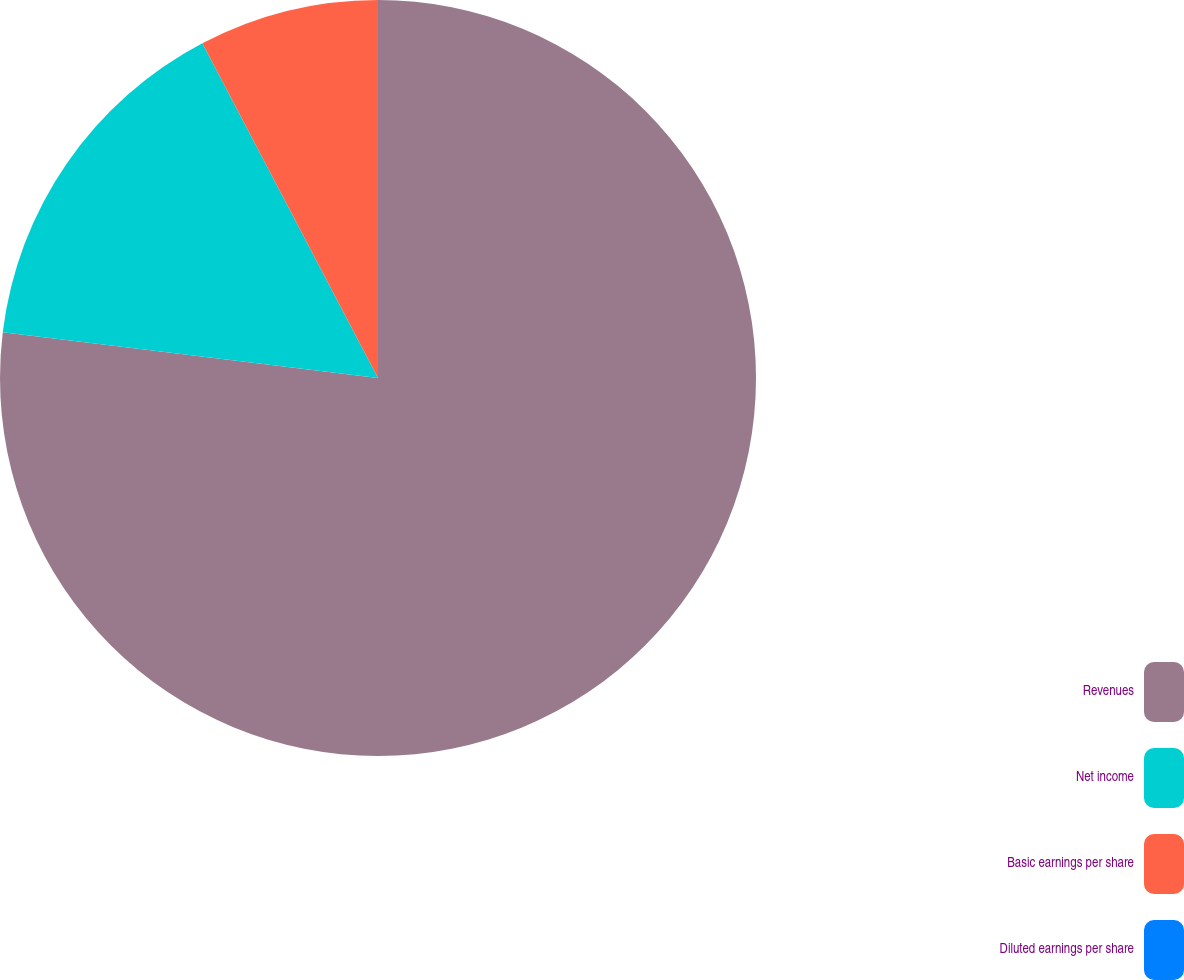Convert chart. <chart><loc_0><loc_0><loc_500><loc_500><pie_chart><fcel>Revenues<fcel>Net income<fcel>Basic earnings per share<fcel>Diluted earnings per share<nl><fcel>76.92%<fcel>15.38%<fcel>7.69%<fcel>0.0%<nl></chart> 